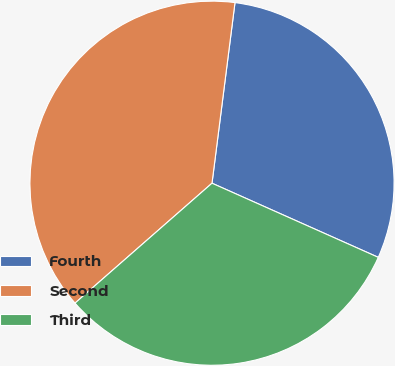Convert chart to OTSL. <chart><loc_0><loc_0><loc_500><loc_500><pie_chart><fcel>Fourth<fcel>Second<fcel>Third<nl><fcel>29.66%<fcel>38.46%<fcel>31.88%<nl></chart> 